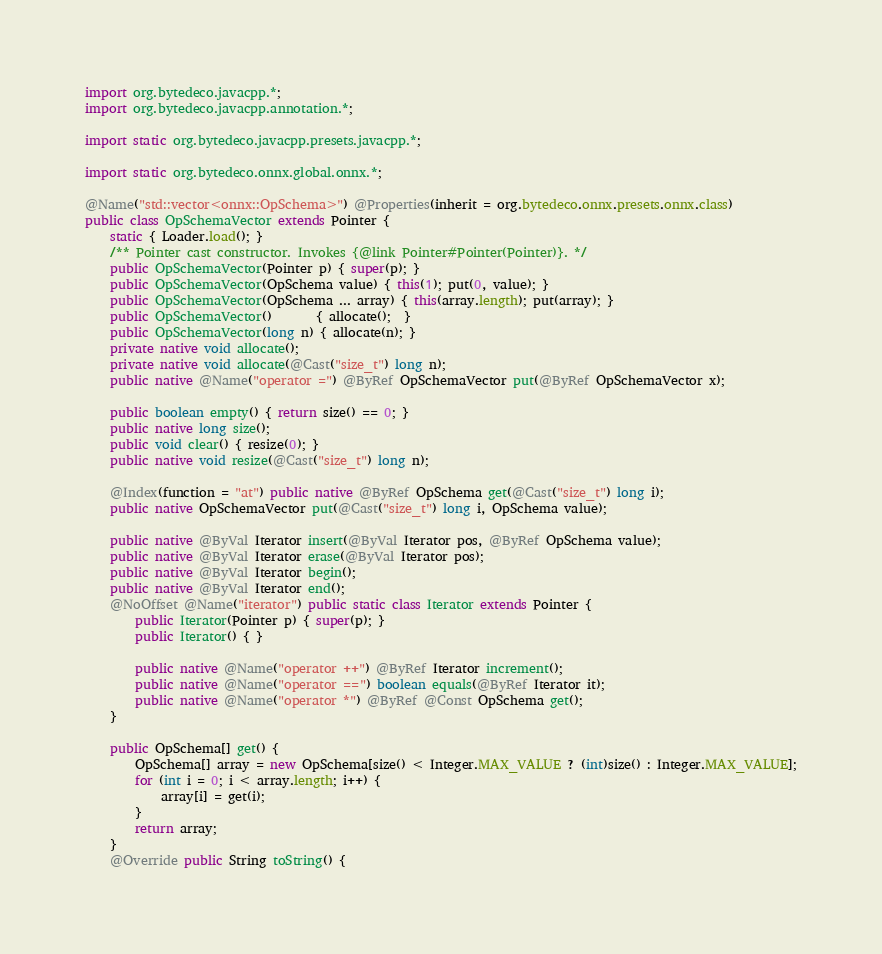Convert code to text. <code><loc_0><loc_0><loc_500><loc_500><_Java_>import org.bytedeco.javacpp.*;
import org.bytedeco.javacpp.annotation.*;

import static org.bytedeco.javacpp.presets.javacpp.*;

import static org.bytedeco.onnx.global.onnx.*;

@Name("std::vector<onnx::OpSchema>") @Properties(inherit = org.bytedeco.onnx.presets.onnx.class)
public class OpSchemaVector extends Pointer {
    static { Loader.load(); }
    /** Pointer cast constructor. Invokes {@link Pointer#Pointer(Pointer)}. */
    public OpSchemaVector(Pointer p) { super(p); }
    public OpSchemaVector(OpSchema value) { this(1); put(0, value); }
    public OpSchemaVector(OpSchema ... array) { this(array.length); put(array); }
    public OpSchemaVector()       { allocate();  }
    public OpSchemaVector(long n) { allocate(n); }
    private native void allocate();
    private native void allocate(@Cast("size_t") long n);
    public native @Name("operator =") @ByRef OpSchemaVector put(@ByRef OpSchemaVector x);

    public boolean empty() { return size() == 0; }
    public native long size();
    public void clear() { resize(0); }
    public native void resize(@Cast("size_t") long n);

    @Index(function = "at") public native @ByRef OpSchema get(@Cast("size_t") long i);
    public native OpSchemaVector put(@Cast("size_t") long i, OpSchema value);

    public native @ByVal Iterator insert(@ByVal Iterator pos, @ByRef OpSchema value);
    public native @ByVal Iterator erase(@ByVal Iterator pos);
    public native @ByVal Iterator begin();
    public native @ByVal Iterator end();
    @NoOffset @Name("iterator") public static class Iterator extends Pointer {
        public Iterator(Pointer p) { super(p); }
        public Iterator() { }

        public native @Name("operator ++") @ByRef Iterator increment();
        public native @Name("operator ==") boolean equals(@ByRef Iterator it);
        public native @Name("operator *") @ByRef @Const OpSchema get();
    }

    public OpSchema[] get() {
        OpSchema[] array = new OpSchema[size() < Integer.MAX_VALUE ? (int)size() : Integer.MAX_VALUE];
        for (int i = 0; i < array.length; i++) {
            array[i] = get(i);
        }
        return array;
    }
    @Override public String toString() {</code> 